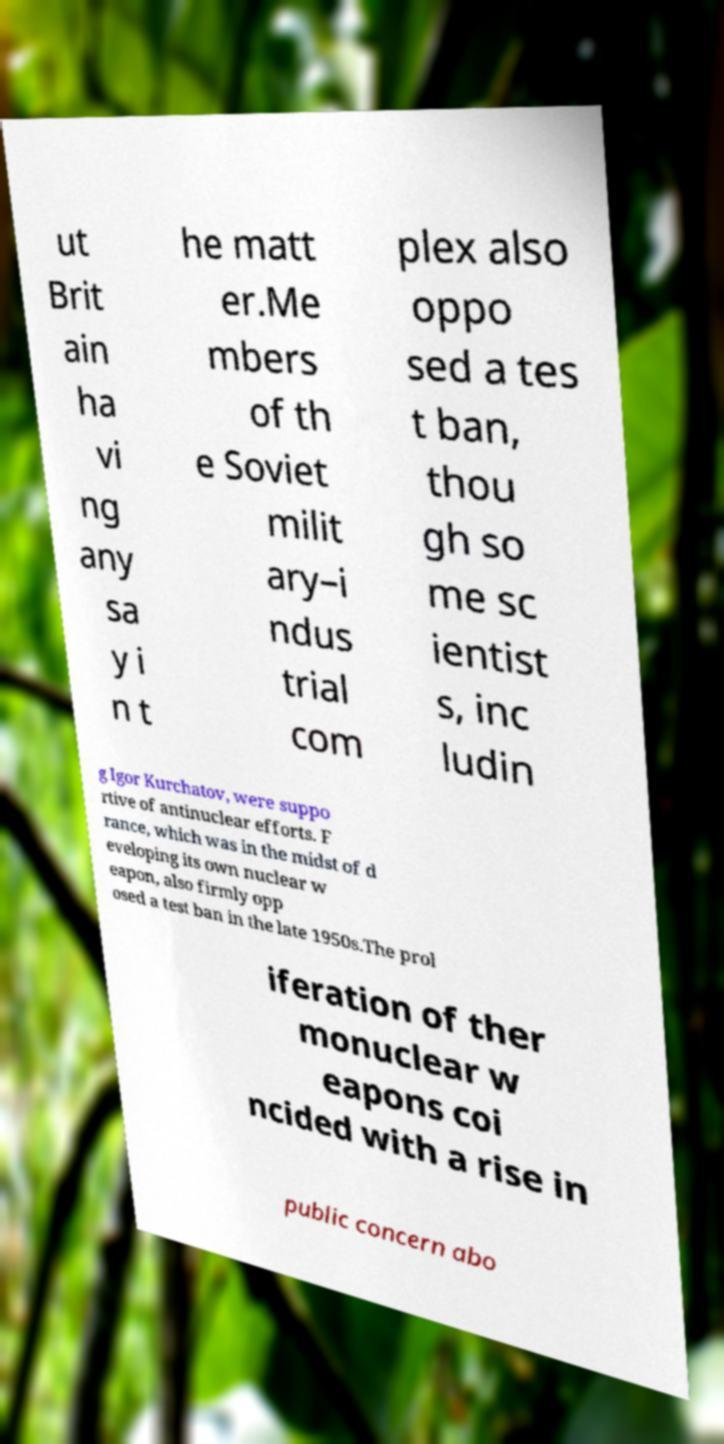Please identify and transcribe the text found in this image. ut Brit ain ha vi ng any sa y i n t he matt er.Me mbers of th e Soviet milit ary–i ndus trial com plex also oppo sed a tes t ban, thou gh so me sc ientist s, inc ludin g Igor Kurchatov, were suppo rtive of antinuclear efforts. F rance, which was in the midst of d eveloping its own nuclear w eapon, also firmly opp osed a test ban in the late 1950s.The prol iferation of ther monuclear w eapons coi ncided with a rise in public concern abo 